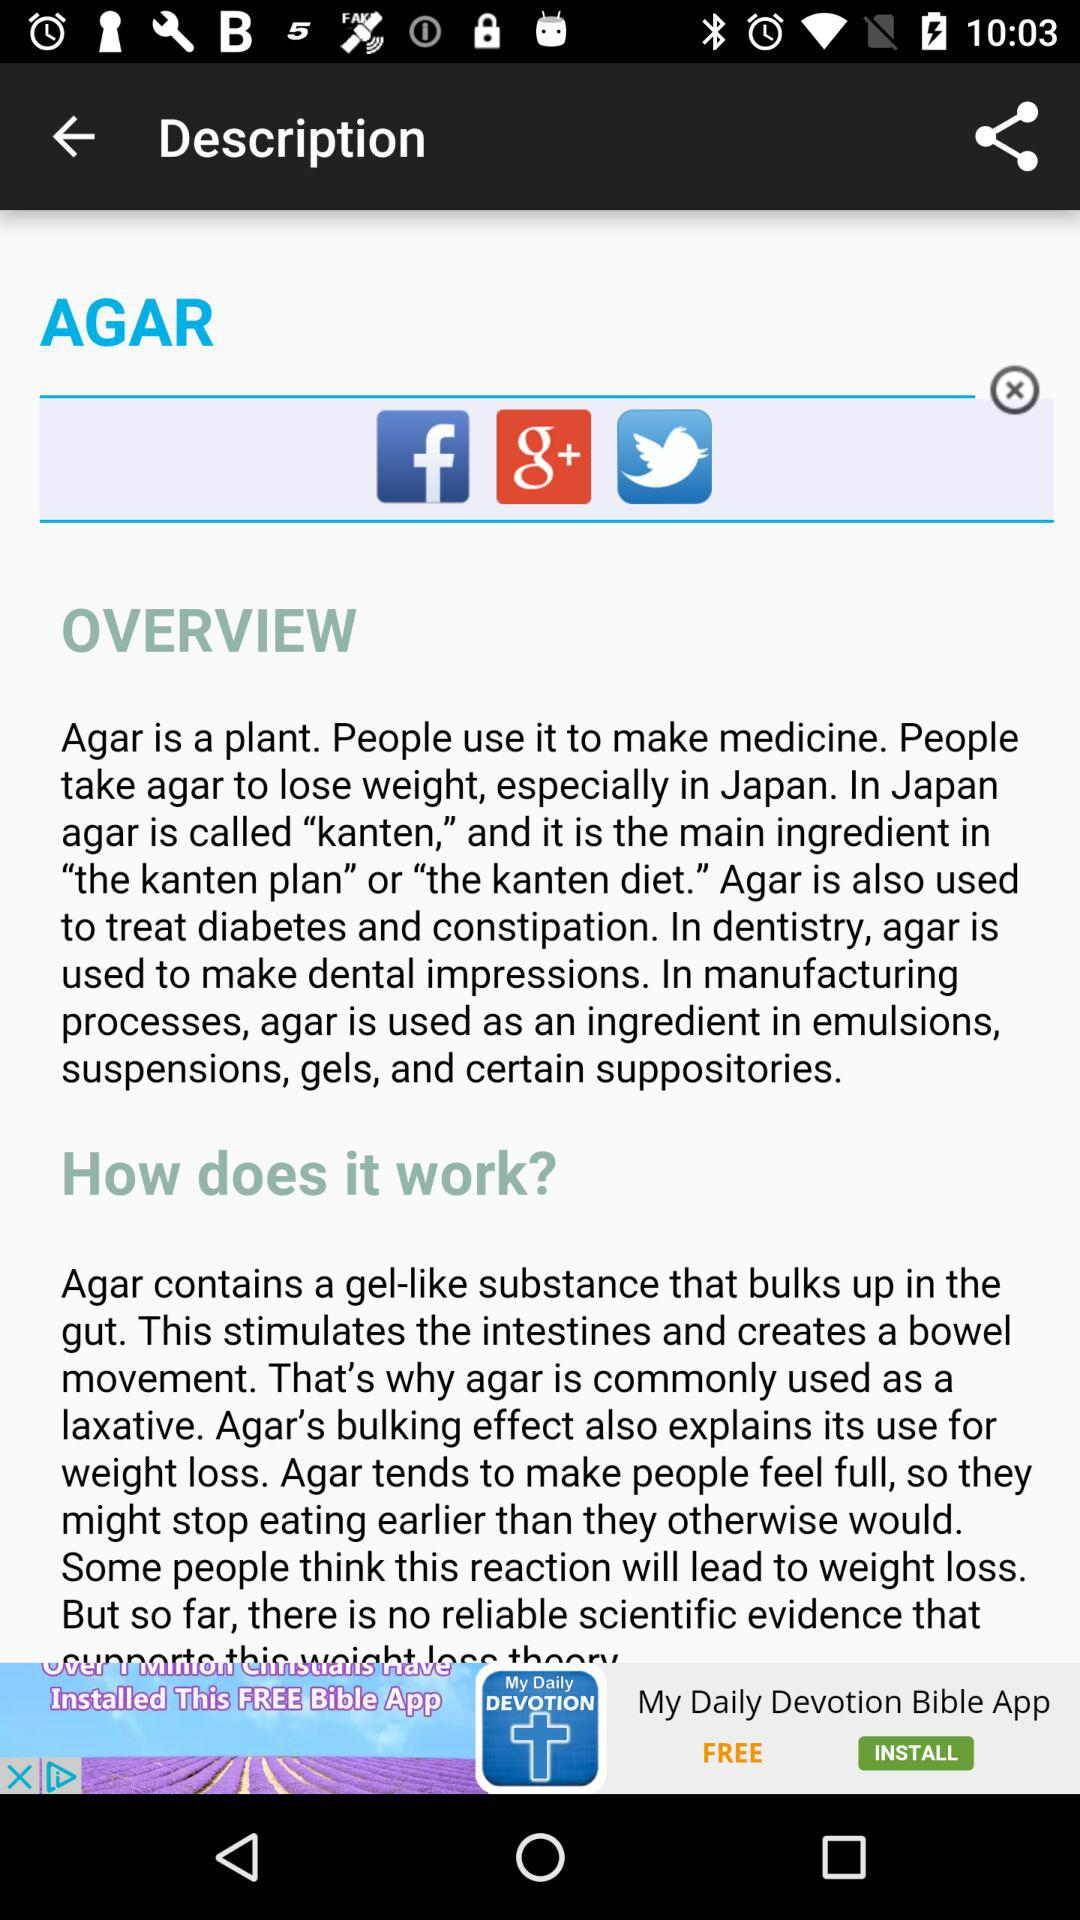What is agar called in Japan? In Japan, agar is called "kanten". 